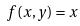Convert formula to latex. <formula><loc_0><loc_0><loc_500><loc_500>f ( x , y ) = x</formula> 